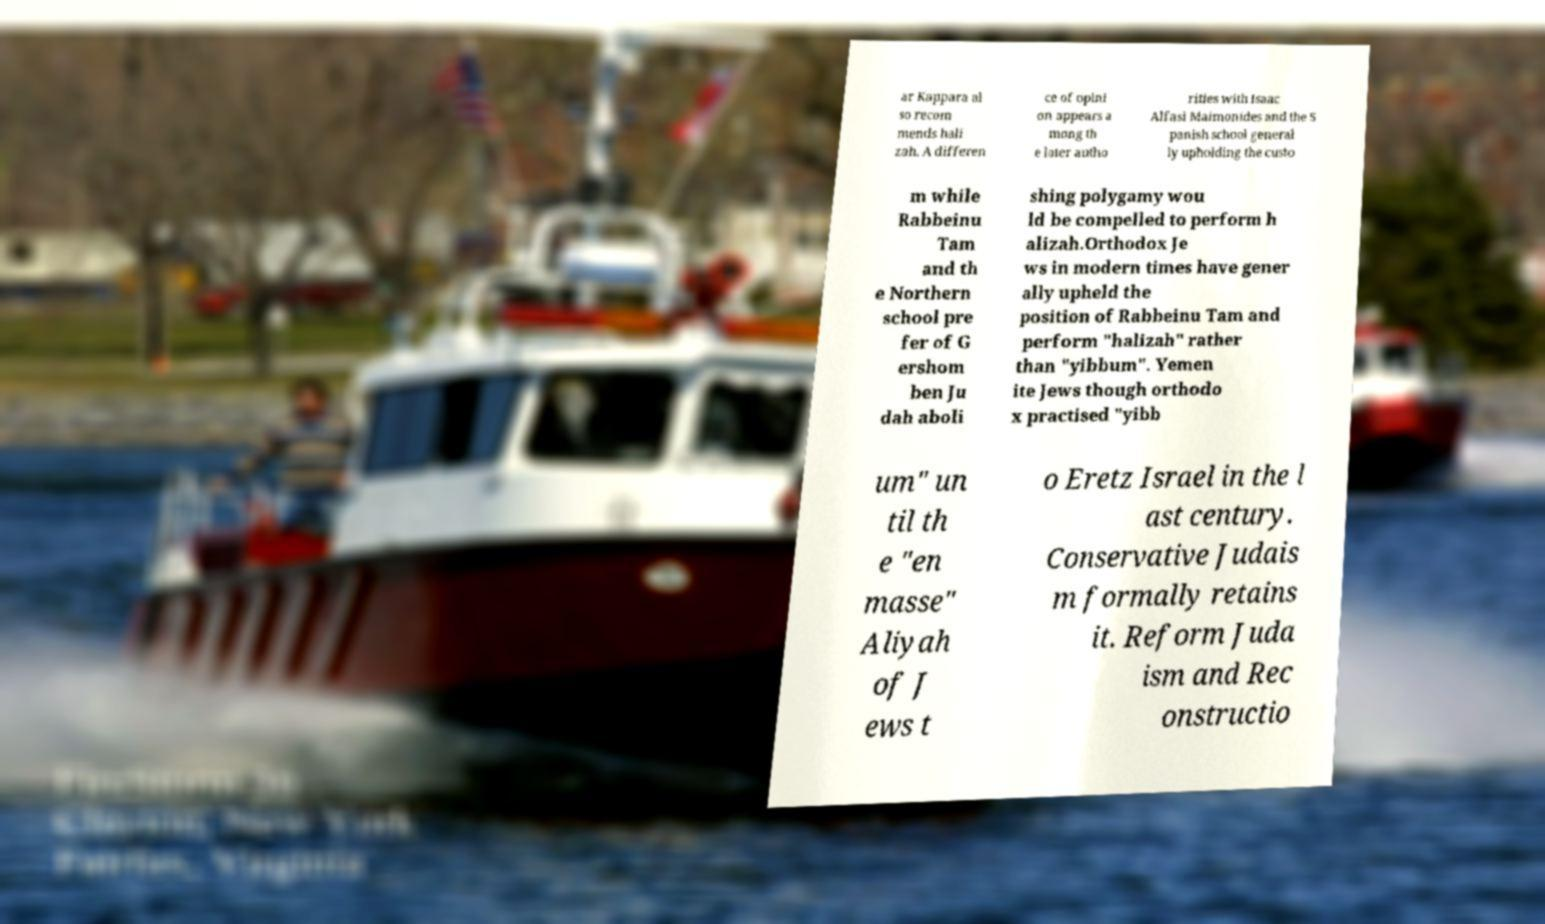Please identify and transcribe the text found in this image. ar Kappara al so recom mends hali zah. A differen ce of opini on appears a mong th e later autho rities with Isaac Alfasi Maimonides and the S panish school general ly upholding the custo m while Rabbeinu Tam and th e Northern school pre fer of G ershom ben Ju dah aboli shing polygamy wou ld be compelled to perform h alizah.Orthodox Je ws in modern times have gener ally upheld the position of Rabbeinu Tam and perform "halizah" rather than "yibbum". Yemen ite Jews though orthodo x practised "yibb um" un til th e "en masse" Aliyah of J ews t o Eretz Israel in the l ast century. Conservative Judais m formally retains it. Reform Juda ism and Rec onstructio 